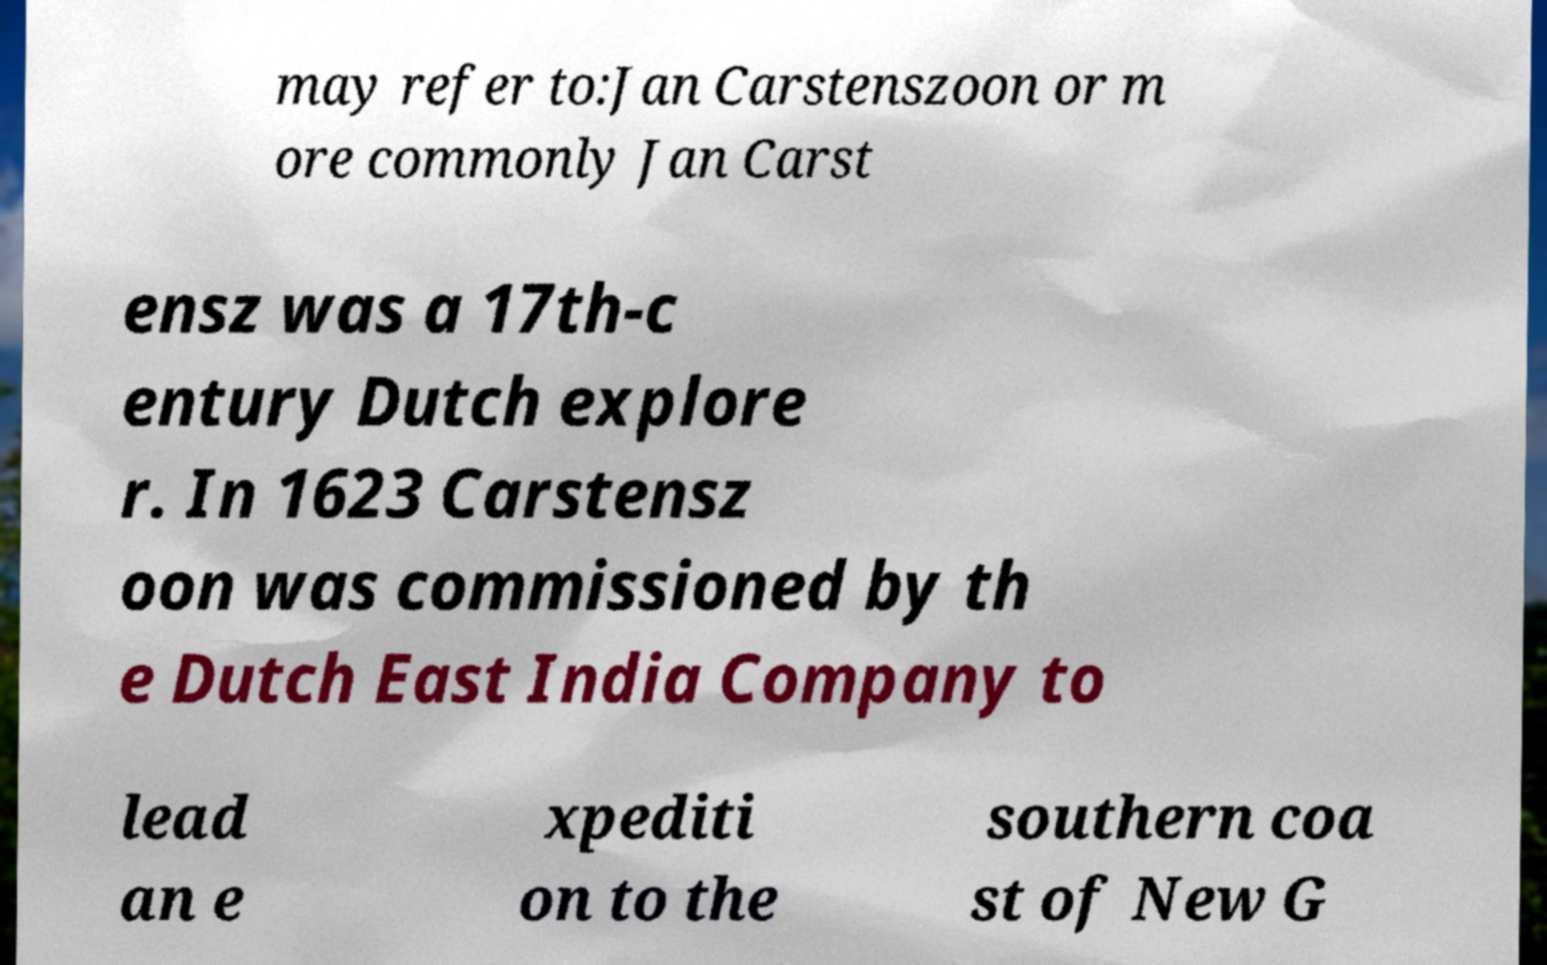There's text embedded in this image that I need extracted. Can you transcribe it verbatim? may refer to:Jan Carstenszoon or m ore commonly Jan Carst ensz was a 17th-c entury Dutch explore r. In 1623 Carstensz oon was commissioned by th e Dutch East India Company to lead an e xpediti on to the southern coa st of New G 